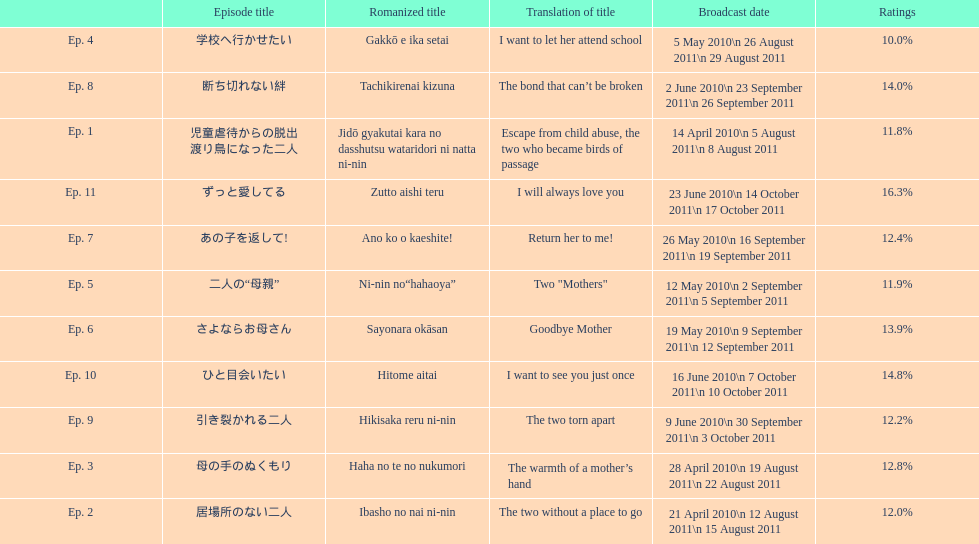How many episodes had a consecutive rating over 11%? 7. 